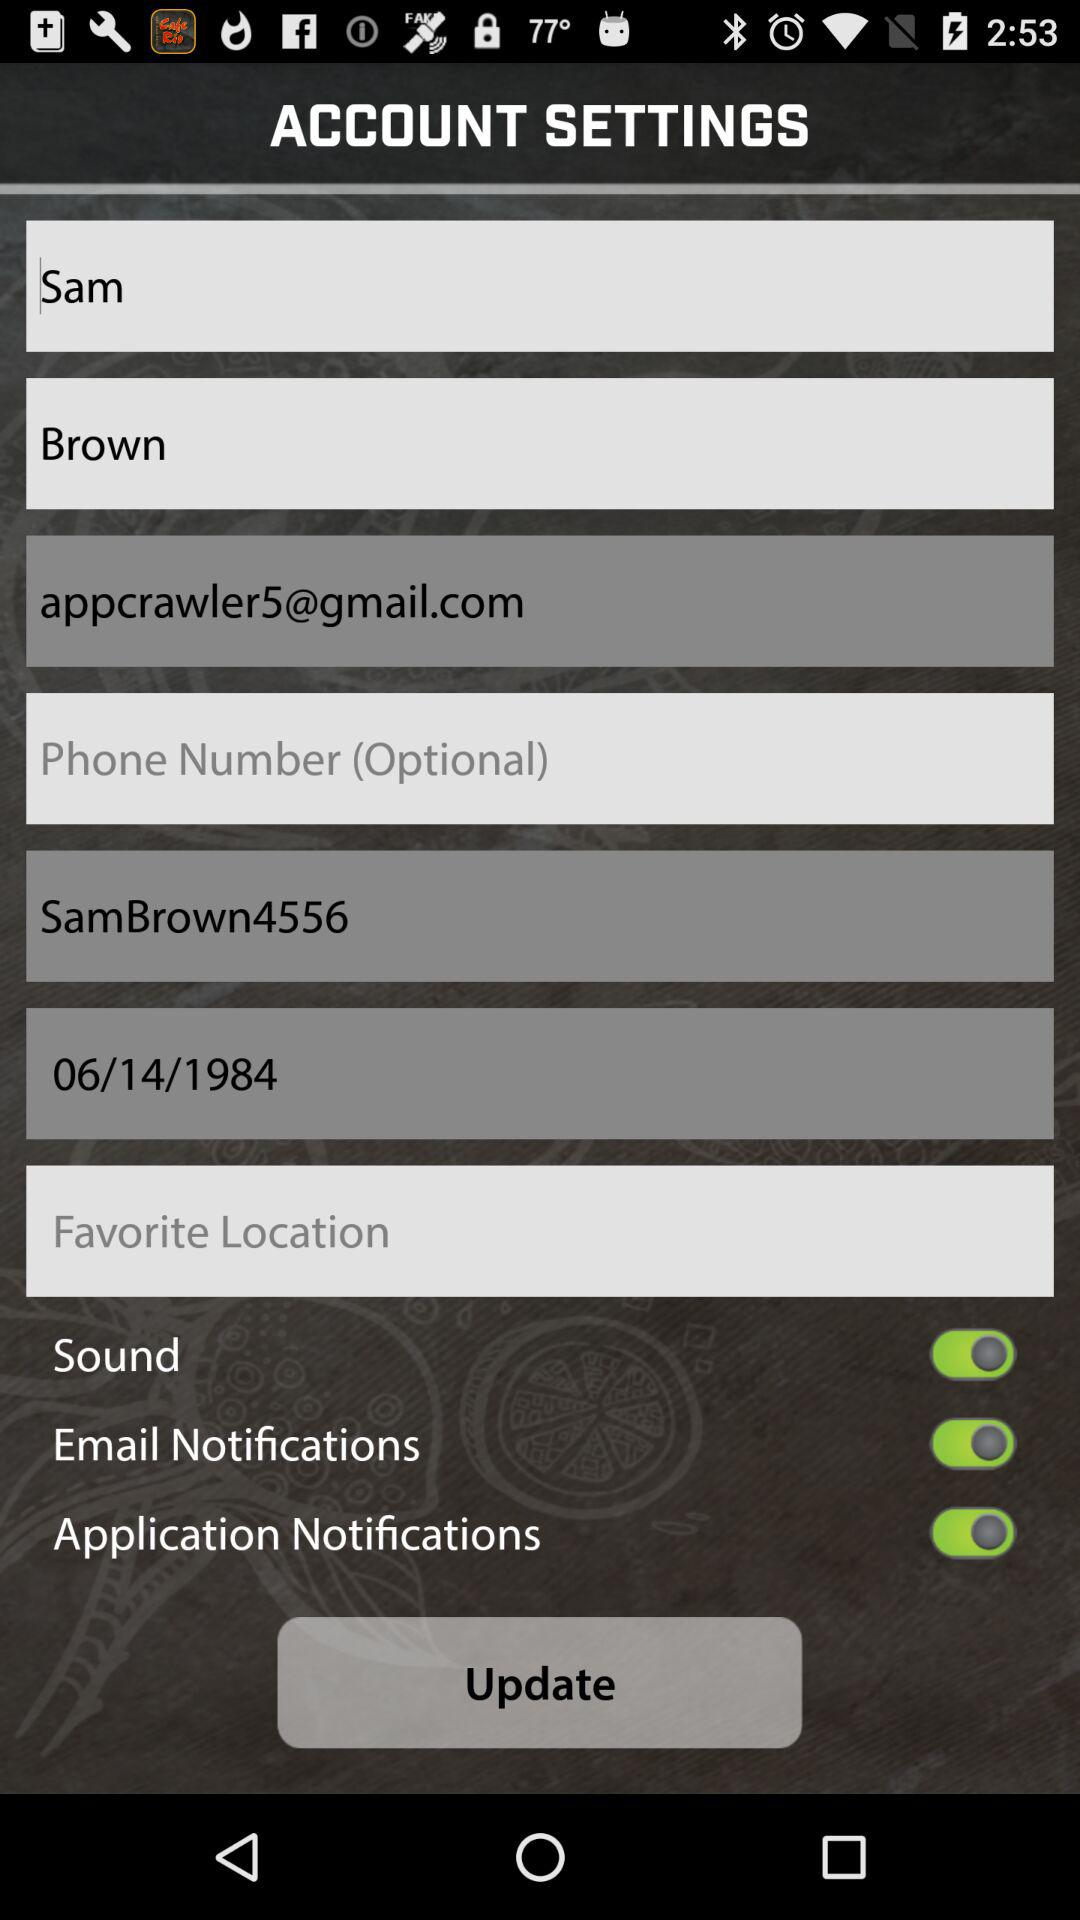What is the status of "Sound"? The status is "on". 